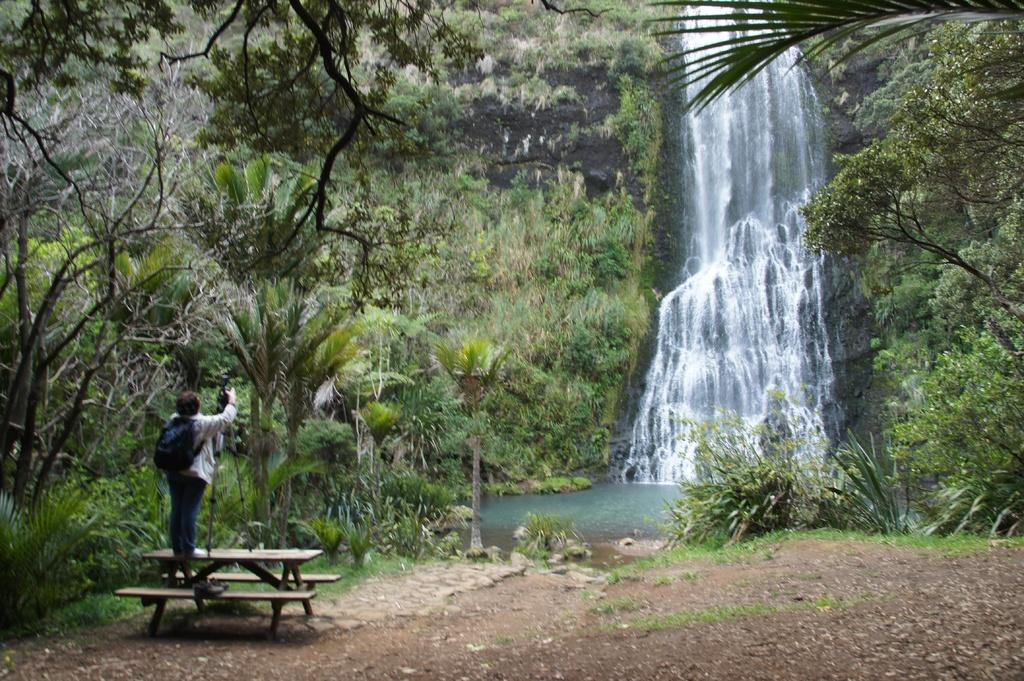What is the person in the image doing? The person is standing on a bench in the image. What is the person carrying on their back? The person is wearing a backpack. What natural feature can be seen in the image? There is a waterfall in the image. What type of vegetation is visible in the background? There are many trees in the background of the image. How many oranges are hanging from the trees in the image? There are no oranges visible in the image; only trees can be seen in the background. 